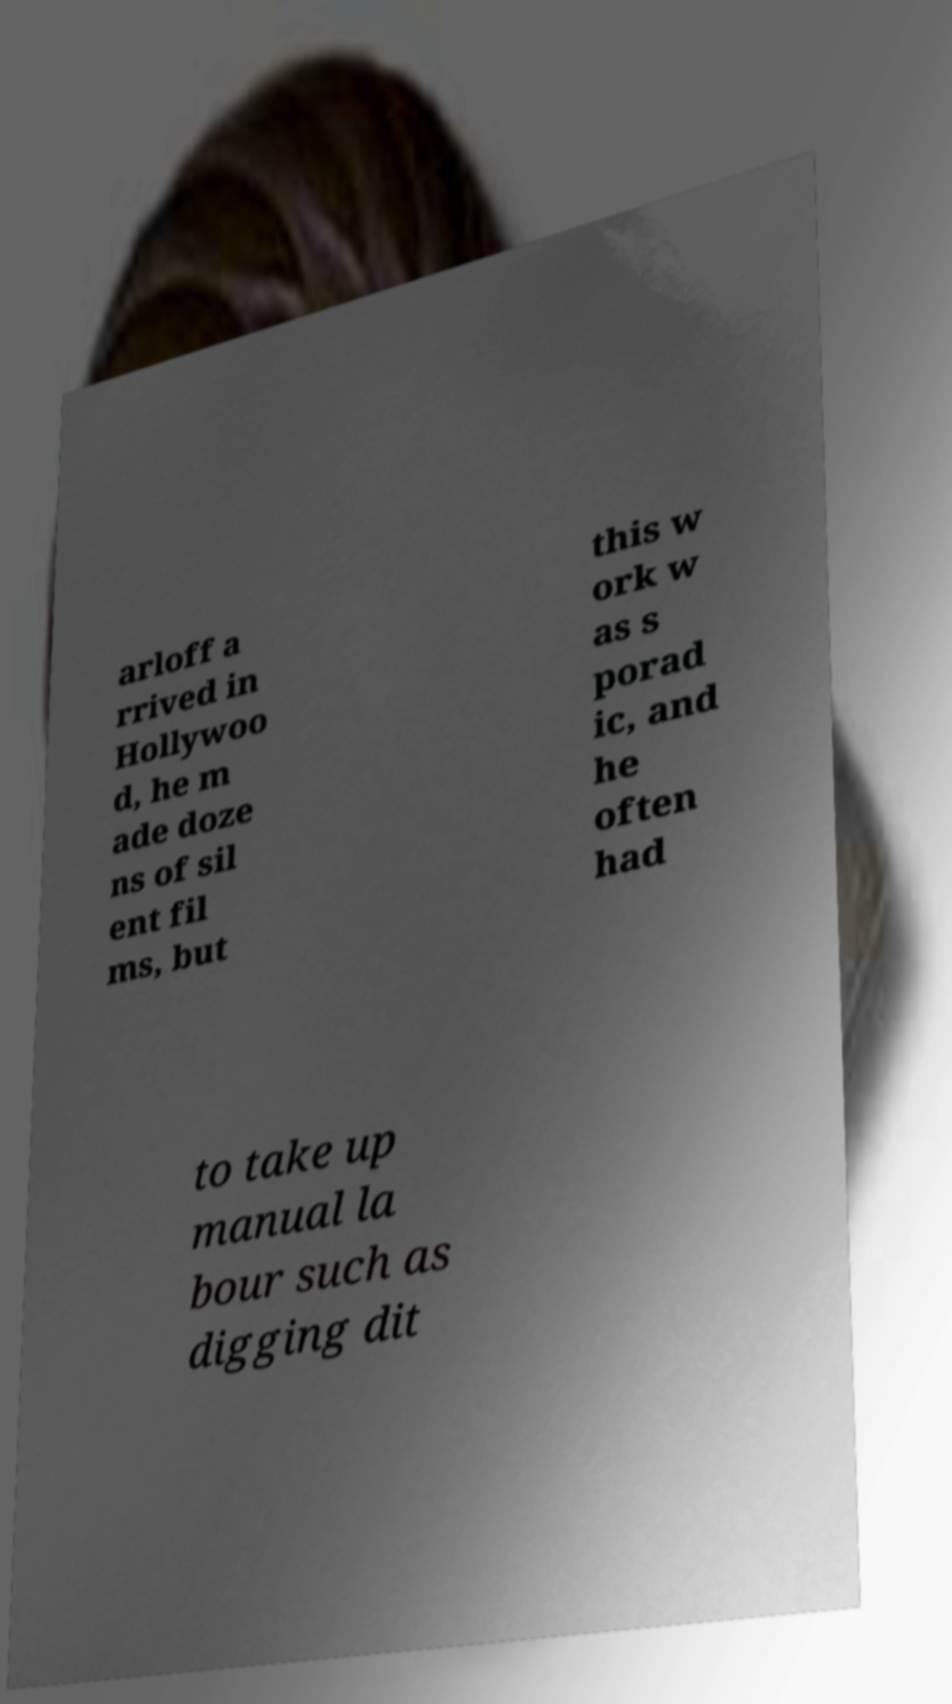Could you extract and type out the text from this image? arloff a rrived in Hollywoo d, he m ade doze ns of sil ent fil ms, but this w ork w as s porad ic, and he often had to take up manual la bour such as digging dit 